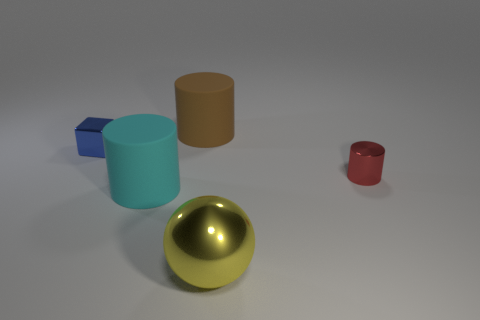Add 4 tiny red shiny cylinders. How many objects exist? 9 Subtract all blocks. How many objects are left? 4 Subtract 0 purple cylinders. How many objects are left? 5 Subtract all brown spheres. Subtract all large yellow balls. How many objects are left? 4 Add 2 metal cubes. How many metal cubes are left? 3 Add 5 brown cylinders. How many brown cylinders exist? 6 